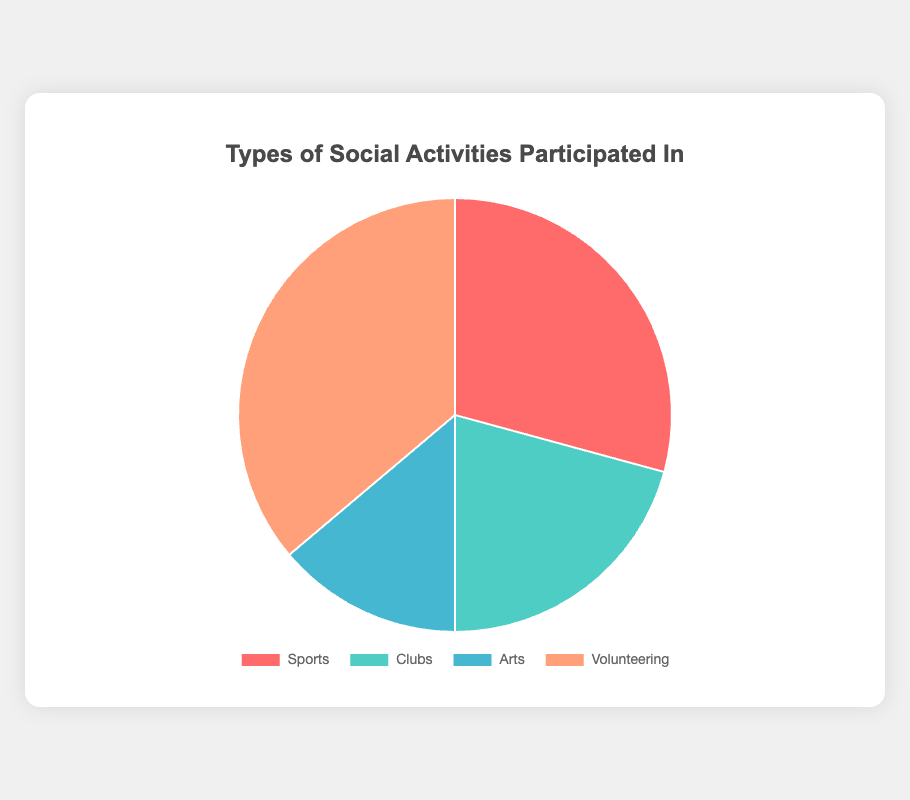Which type of social activity has the highest number of participants? The pie chart shows the different types of social activities along with their respective participation numbers. By comparing them visually, we see that "Volunteering" has the largest portion of the pie chart.
Answer: Volunteering How many more participants are there in Sports activities compared to Arts activities? By looking at the pie chart, we see that Sports have two segments (Basketball Club and Soccer Team) with 20 and 18 participants respectively, summing to 38. Arts have two segments (Painting Class and Drama Club) with 10 and 8 participants respectively, summing to 18. The difference is 38 - 18.
Answer: 20 Which social activity type has the least participation? From the pie chart, the segment representing "Arts" is the smallest, indicating it has the least number of participants.
Answer: Arts What is the total number of participants across all types of activities? Sum the number of participants from all activity types shown in the pie chart. Sports: 20 + 18 = 38, Clubs: 15 + 12 = 27, Arts: 10 + 8 = 18, Volunteering: 25 + 22 = 47. Total participants are 38 + 27 + 18 + 47.
Answer: 130 What percentage of participants are involved in Clubs? From the aggregated data, Clubs have 27 participants out of a total of 130. The percentage is (27 / 130) * 100.
Answer: 20.77% Combine the numbers of participants in Debate Club and Soccer Team. How does this compare to the number of participants in Community Clean-Up? Debate Club has 15 participants and Soccer Team has 18, summing to 33. Community Clean-Up has 25 participants, so compare 33 (Debate + Soccer) with 25 (Community Clean-Up).
Answer: 33 > 25 Which color represents the participants involved in the Drama Club? By referencing the visual attributes of the pie chart, the Drama Club is part of the Arts segment, which is represented by the color blue.
Answer: Blue Is the number of participants in Basketball Club more or less than those in the Animal Shelter Help activity? Look at the pie chart to compare the respective segments. Basketball Club has 20 participants, and Animal Shelter Help has 22 participants.
Answer: Less Calculate the average number of participants per type of activity (across Sports, Clubs, Arts, and Volunteering). Total participants for each type: Sports: 38, Clubs: 27, Arts: 18, Volunteering: 47. The average is (38 + 27 + 18 + 47) / 4.
Answer: 32.5 